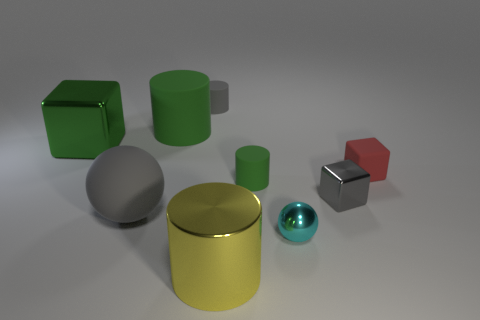Subtract all rubber cylinders. How many cylinders are left? 1 Subtract all cylinders. How many objects are left? 5 Add 8 red matte blocks. How many red matte blocks exist? 9 Add 1 small green cylinders. How many objects exist? 10 Subtract all cyan spheres. How many spheres are left? 1 Subtract 0 blue cylinders. How many objects are left? 9 Subtract 3 cubes. How many cubes are left? 0 Subtract all green cubes. Subtract all gray cylinders. How many cubes are left? 2 Subtract all green blocks. How many red spheres are left? 0 Subtract all matte balls. Subtract all objects. How many objects are left? 7 